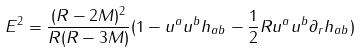Convert formula to latex. <formula><loc_0><loc_0><loc_500><loc_500>E ^ { 2 } = \frac { ( R - 2 M ) ^ { 2 } } { R ( R - 3 M ) } ( 1 - { u } ^ { a } { u } ^ { b } h _ { a b } - \frac { 1 } { 2 } R { u } ^ { a } { u } ^ { b } \partial _ { r } h _ { a b } )</formula> 